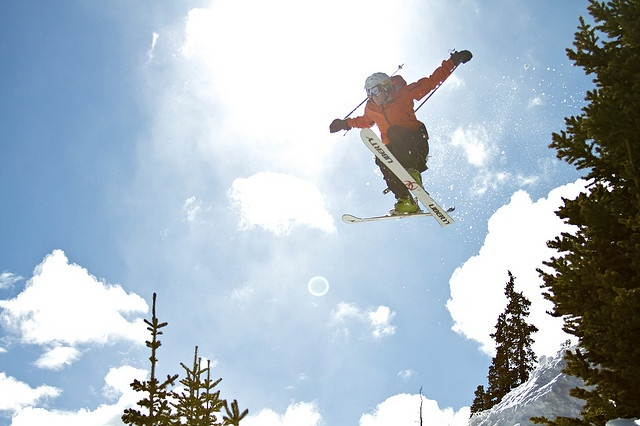Describe the objects in this image and their specific colors. I can see people in gray, brown, and white tones and skis in gray, darkgray, and lightgray tones in this image. 